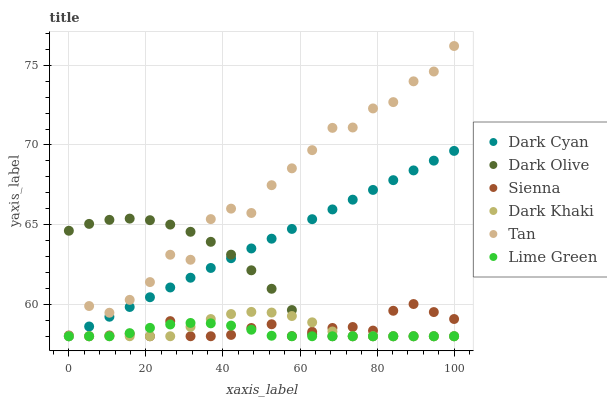Does Lime Green have the minimum area under the curve?
Answer yes or no. Yes. Does Tan have the maximum area under the curve?
Answer yes or no. Yes. Does Dark Olive have the minimum area under the curve?
Answer yes or no. No. Does Dark Olive have the maximum area under the curve?
Answer yes or no. No. Is Dark Cyan the smoothest?
Answer yes or no. Yes. Is Tan the roughest?
Answer yes or no. Yes. Is Dark Olive the smoothest?
Answer yes or no. No. Is Dark Olive the roughest?
Answer yes or no. No. Does Dark Khaki have the lowest value?
Answer yes or no. Yes. Does Tan have the highest value?
Answer yes or no. Yes. Does Dark Olive have the highest value?
Answer yes or no. No. Does Dark Olive intersect Sienna?
Answer yes or no. Yes. Is Dark Olive less than Sienna?
Answer yes or no. No. Is Dark Olive greater than Sienna?
Answer yes or no. No. 